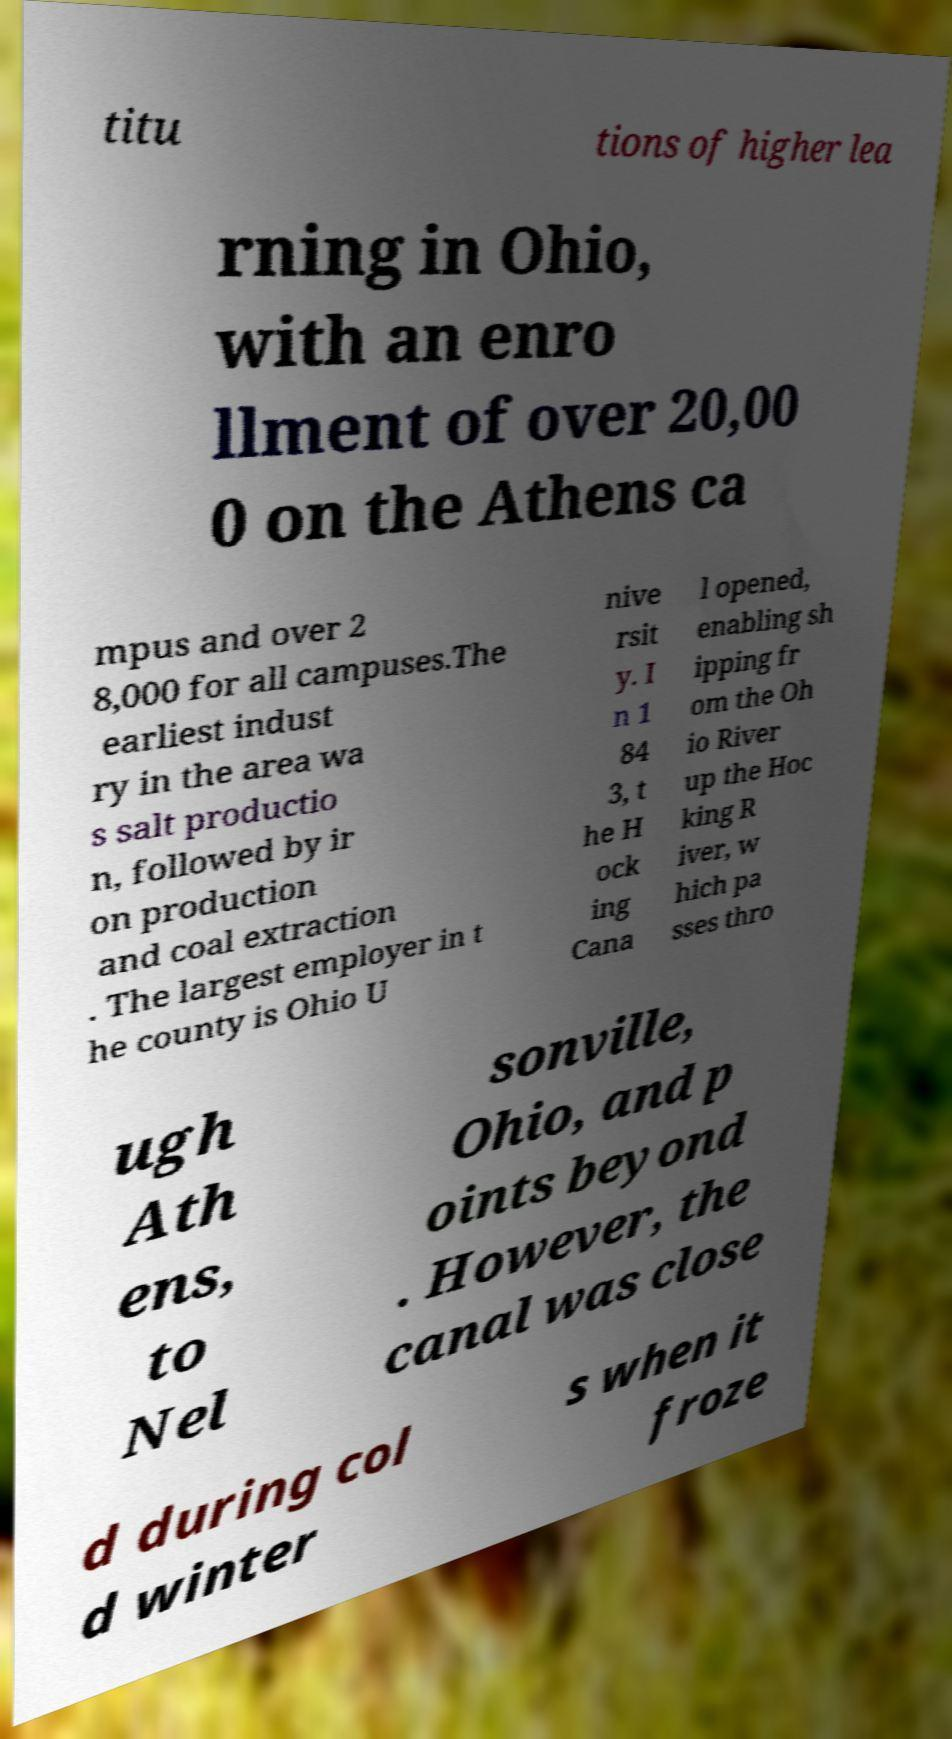Could you extract and type out the text from this image? titu tions of higher lea rning in Ohio, with an enro llment of over 20,00 0 on the Athens ca mpus and over 2 8,000 for all campuses.The earliest indust ry in the area wa s salt productio n, followed by ir on production and coal extraction . The largest employer in t he county is Ohio U nive rsit y. I n 1 84 3, t he H ock ing Cana l opened, enabling sh ipping fr om the Oh io River up the Hoc king R iver, w hich pa sses thro ugh Ath ens, to Nel sonville, Ohio, and p oints beyond . However, the canal was close d during col d winter s when it froze 